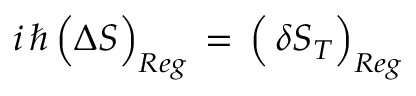<formula> <loc_0><loc_0><loc_500><loc_500>i \, \hbar { \, } \left ( \Delta S \right ) _ { R e g } \, = \, \left ( \, \delta S _ { T } \right ) _ { R e g }</formula> 